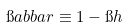<formula> <loc_0><loc_0><loc_500><loc_500>\i a b b a r \equiv 1 - \i h</formula> 